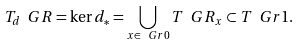Convert formula to latex. <formula><loc_0><loc_0><loc_500><loc_500>T _ { d } \ G R = \ker d _ { * } = \bigcup _ { x \in \ G r 0 } T \ G R _ { x } \subset T \ G r 1 .</formula> 